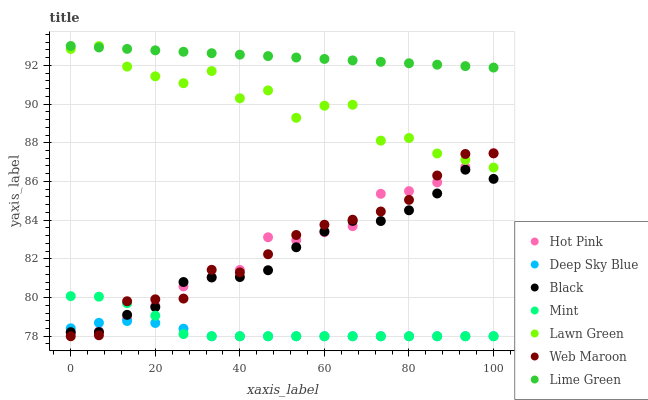Does Deep Sky Blue have the minimum area under the curve?
Answer yes or no. Yes. Does Lime Green have the maximum area under the curve?
Answer yes or no. Yes. Does Hot Pink have the minimum area under the curve?
Answer yes or no. No. Does Hot Pink have the maximum area under the curve?
Answer yes or no. No. Is Lime Green the smoothest?
Answer yes or no. Yes. Is Lawn Green the roughest?
Answer yes or no. Yes. Is Hot Pink the smoothest?
Answer yes or no. No. Is Hot Pink the roughest?
Answer yes or no. No. Does Web Maroon have the lowest value?
Answer yes or no. Yes. Does Hot Pink have the lowest value?
Answer yes or no. No. Does Lime Green have the highest value?
Answer yes or no. Yes. Does Hot Pink have the highest value?
Answer yes or no. No. Is Mint less than Lawn Green?
Answer yes or no. Yes. Is Lawn Green greater than Mint?
Answer yes or no. Yes. Does Deep Sky Blue intersect Web Maroon?
Answer yes or no. Yes. Is Deep Sky Blue less than Web Maroon?
Answer yes or no. No. Is Deep Sky Blue greater than Web Maroon?
Answer yes or no. No. Does Mint intersect Lawn Green?
Answer yes or no. No. 